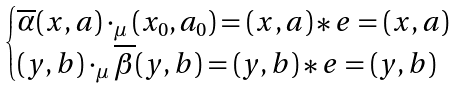Convert formula to latex. <formula><loc_0><loc_0><loc_500><loc_500>\begin{cases} \overline { \alpha } ( x , a ) \cdot _ { \mu } ( x _ { 0 } , a _ { 0 } ) = ( x , a ) \ast e = ( x , a ) \\ ( y , b ) \cdot _ { \mu } \overline { \beta } ( y , b ) = ( y , b ) \ast e = ( y , b ) \end{cases}</formula> 